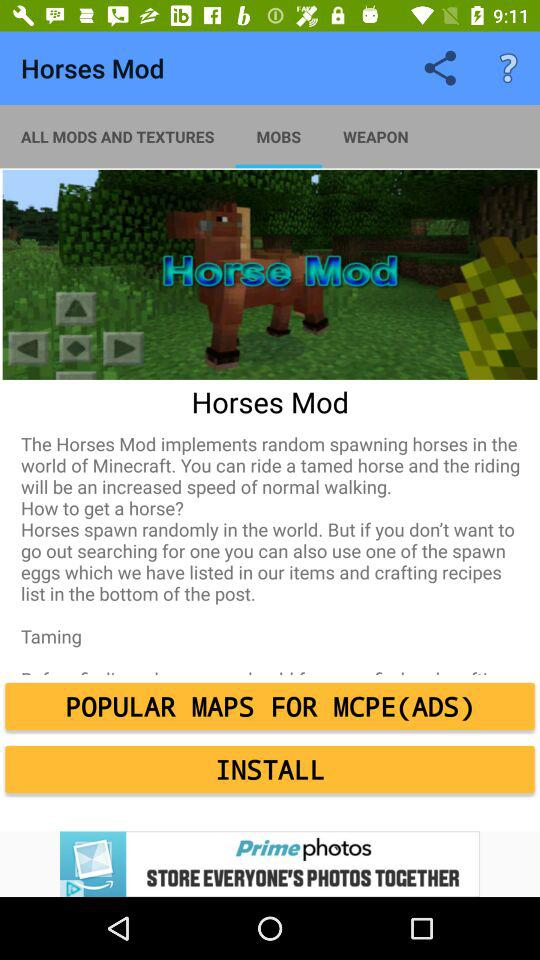What is the "Horses Mod"? The "Horses Mod" is "The Horses Mod implements random spawning horses in the world of Minecraft. You can ride a tamed horse and the riding will be an increased speed of normal walking.". 